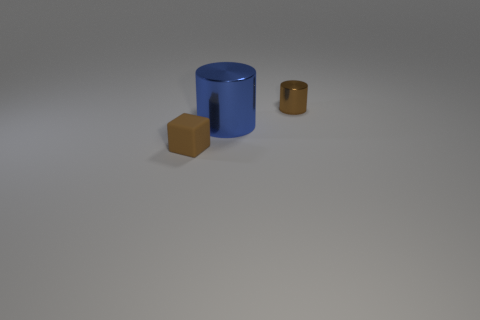What is the size of the other blue thing that is the same shape as the tiny metal object?
Ensure brevity in your answer.  Large. There is another tiny object that is the same color as the small rubber object; what shape is it?
Make the answer very short. Cylinder. What number of brown shiny cylinders have the same size as the rubber thing?
Provide a succinct answer. 1. The tiny brown thing that is behind the small cube has what shape?
Your response must be concise. Cylinder. Is the number of red shiny balls less than the number of large metal cylinders?
Your response must be concise. Yes. Is there anything else that is the same color as the big cylinder?
Your answer should be very brief. No. There is a blue cylinder behind the tiny brown matte thing; what size is it?
Provide a short and direct response. Large. Is the number of objects greater than the number of tiny green cylinders?
Provide a succinct answer. Yes. What material is the small cylinder?
Keep it short and to the point. Metal. What number of other things are the same material as the blue cylinder?
Offer a terse response. 1. 